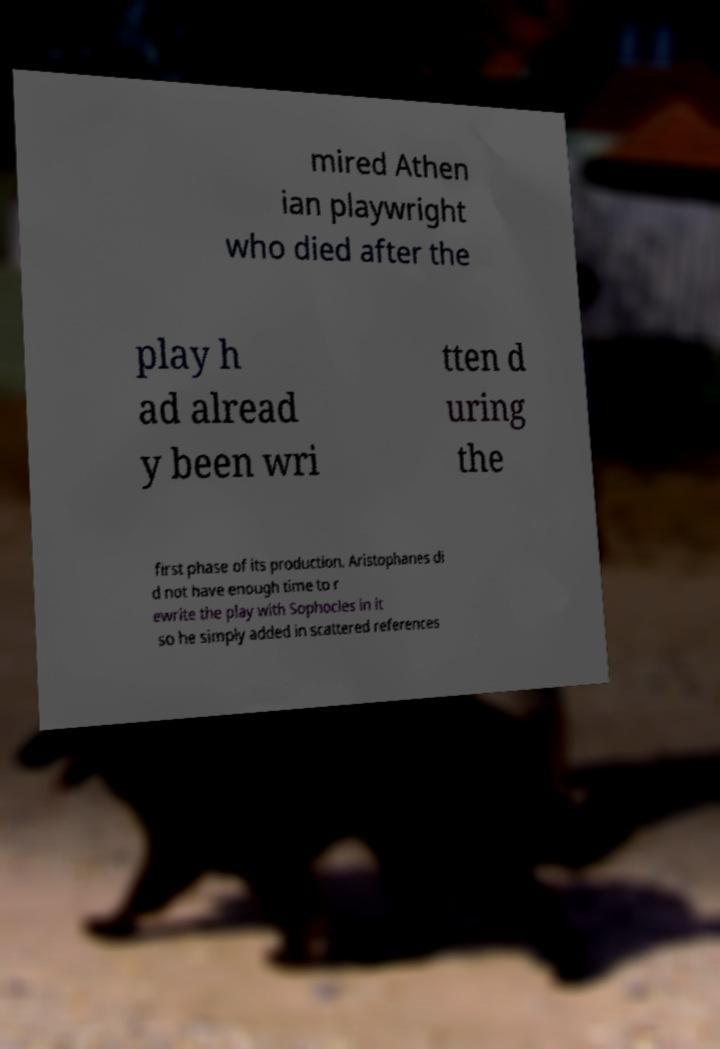There's text embedded in this image that I need extracted. Can you transcribe it verbatim? mired Athen ian playwright who died after the play h ad alread y been wri tten d uring the first phase of its production. Aristophanes di d not have enough time to r ewrite the play with Sophocles in it so he simply added in scattered references 